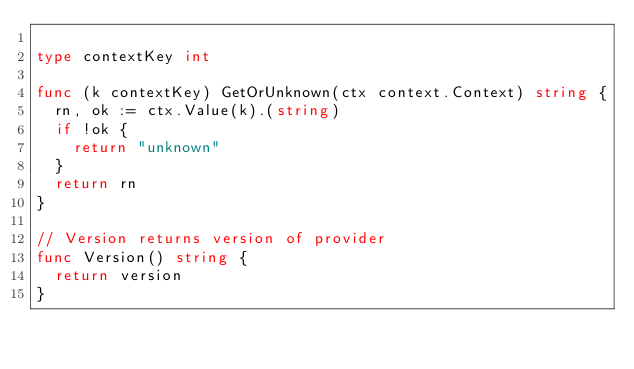<code> <loc_0><loc_0><loc_500><loc_500><_Go_>
type contextKey int

func (k contextKey) GetOrUnknown(ctx context.Context) string {
	rn, ok := ctx.Value(k).(string)
	if !ok {
		return "unknown"
	}
	return rn
}

// Version returns version of provider
func Version() string {
	return version
}
</code> 